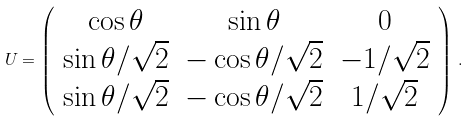<formula> <loc_0><loc_0><loc_500><loc_500>U = \left ( \begin{array} { c c c } \cos \theta & \sin \theta & 0 \\ \sin \theta / \sqrt { 2 } & - \cos \theta / \sqrt { 2 } & - 1 / \sqrt { 2 } \\ \sin \theta / \sqrt { 2 } & - \cos \theta / \sqrt { 2 } & 1 / \sqrt { 2 } \end{array} \right ) \, .</formula> 